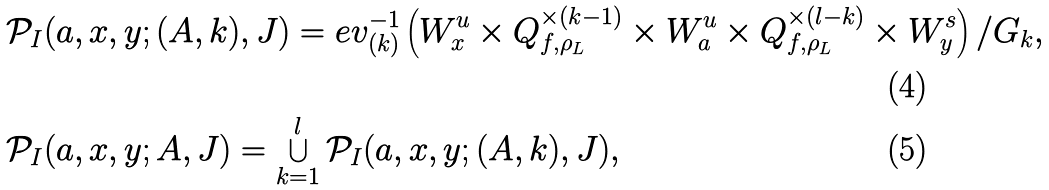<formula> <loc_0><loc_0><loc_500><loc_500>& \mathcal { P } _ { I } ( a , x , y ; ( A , k ) , J ) = e v _ { ( k ) } ^ { - 1 } \left ( W _ { x } ^ { u } \times Q _ { f , \rho _ { L } } ^ { \times ( k - 1 ) } \times W _ { a } ^ { u } \times Q _ { f , \rho _ { L } } ^ { \times ( l - k ) } \times W _ { y } ^ { s } \right ) / G _ { k } , \\ & \mathcal { P } _ { I } ( a , x , y ; A , J ) = \bigcup _ { k = 1 } ^ { l } \mathcal { P } _ { I } ( a , x , y ; ( A , k ) , J ) ,</formula> 